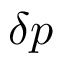Convert formula to latex. <formula><loc_0><loc_0><loc_500><loc_500>\delta p</formula> 